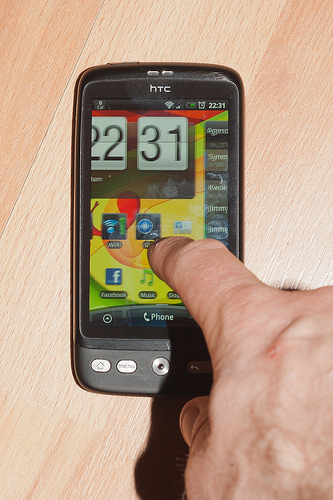<image>
Is the man under the phone? No. The man is not positioned under the phone. The vertical relationship between these objects is different. 